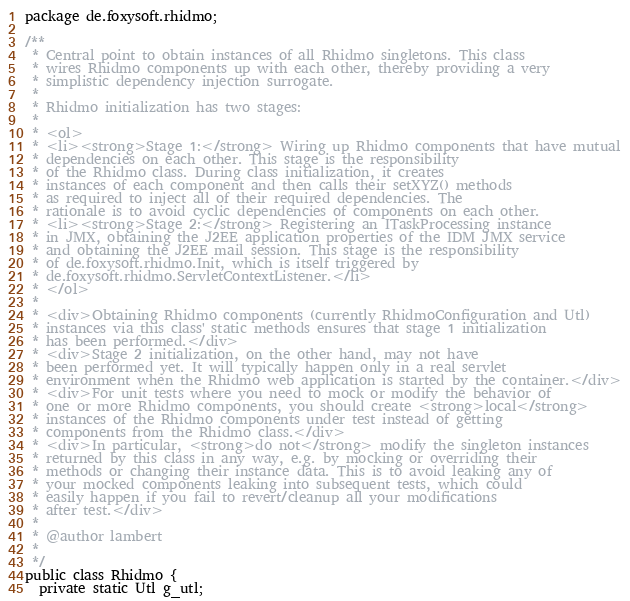<code> <loc_0><loc_0><loc_500><loc_500><_Java_>package de.foxysoft.rhidmo;

/**
 * Central point to obtain instances of all Rhidmo singletons. This class
 * wires Rhidmo components up with each other, thereby providing a very
 * simplistic dependency injection surrogate.
 * 
 * Rhidmo initialization has two stages:
 * 
 * <ol>
 * <li><strong>Stage 1:</strong> Wiring up Rhidmo components that have mutual
 * dependencies on each other. This stage is the responsibility
 * of the Rhidmo class. During class initialization, it creates
 * instances of each component and then calls their setXYZ() methods 
 * as required to inject all of their required dependencies. The
 * rationale is to avoid cyclic dependencies of components on each other.
 * <li><strong>Stage 2:</strong> Registering an ITaskProcessing instance 
 * in JMX, obtaining the J2EE application properties of the IDM JMX service
 * and obtaining the J2EE mail session. This stage is the responsibility
 * of de.foxysoft.rhidmo.Init, which is itself triggered by
 * de.foxysoft.rhidmo.ServletContextListener.</li>
 * </ol>
 * 
 * <div>Obtaining Rhidmo components (currently RhidmoConfiguration and Utl)
 * instances via this class' static methods ensures that stage 1 initialization
 * has been performed.</div>
 * <div>Stage 2 initialization, on the other hand, may not have
 * been performed yet. It will typically happen only in a real servlet
 * environment when the Rhidmo web application is started by the container.</div>
 * <div>For unit tests where you need to mock or modify the behavior of
 * one or more Rhidmo components, you should create <strong>local</strong> 
 * instances of the Rhidmo components under test instead of getting
 * components from the Rhidmo class.</div>
 * <div>In particular, <strong>do not</strong> modify the singleton instances
 * returned by this class in any way, e.g. by mocking or overriding their
 * methods or changing their instance data. This is to avoid leaking any of
 * your mocked components leaking into subsequent tests, which could
 * easily happen if you fail to revert/cleanup all your modifications
 * after test.</div>   
 * 
 * @author lambert
 *
 */
public class Rhidmo {
  private static Utl g_utl;</code> 